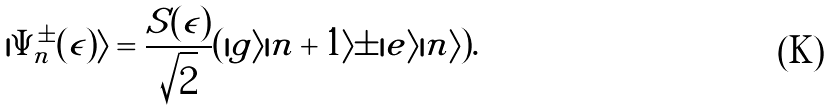<formula> <loc_0><loc_0><loc_500><loc_500>| \Psi _ { n } ^ { \pm } ( \epsilon ) \rangle = \frac { S ( \epsilon ) } { \sqrt { 2 } } ( | g \rangle | n + 1 \rangle \pm | e \rangle | n \rangle ) .</formula> 